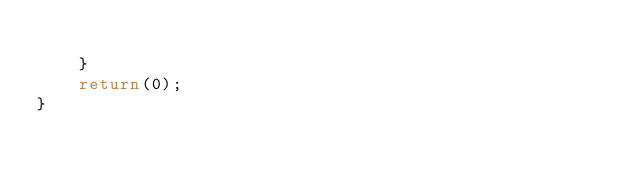<code> <loc_0><loc_0><loc_500><loc_500><_C++_>
    }
    return(0);
}
</code> 